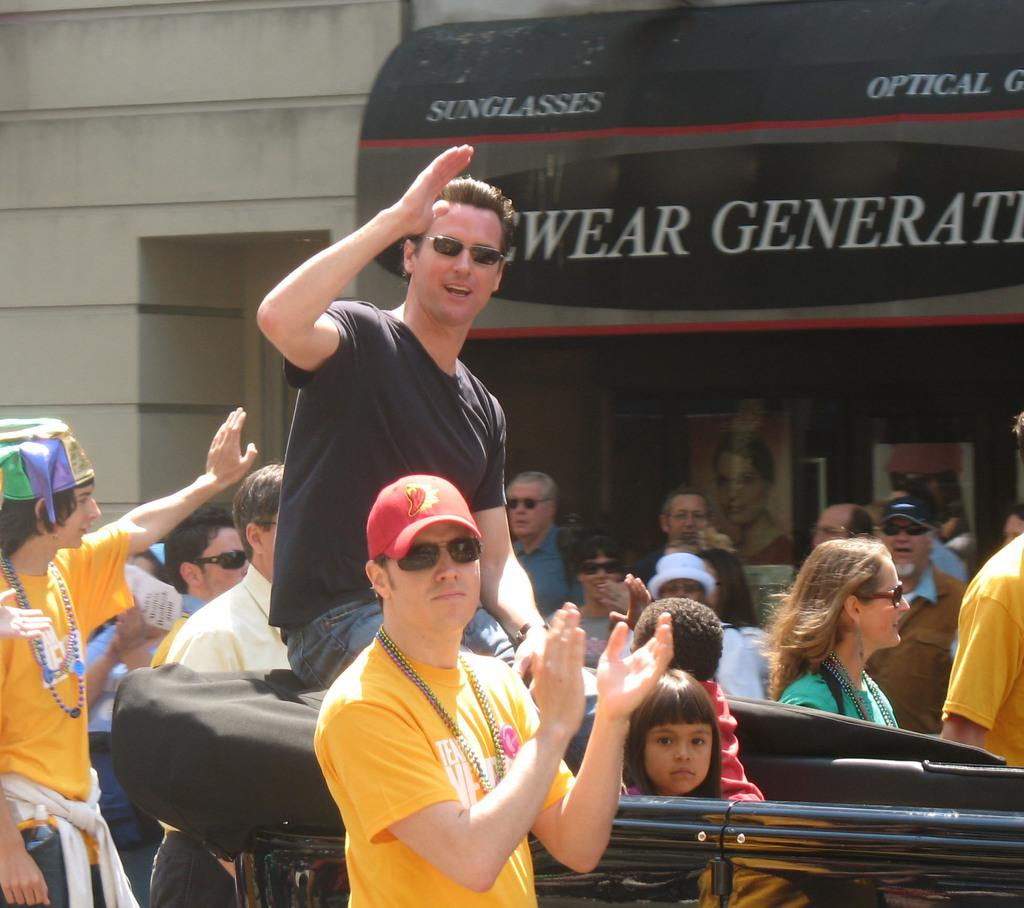What are the people in the image doing? There are people walking on the road and traveling in a vehicle in the image. Can you describe the mode of transportation in the image? The people are traveling in a vehicle, but the specific type of vehicle is not mentioned in the facts. How many people are visible in the image? The number of people visible in the image is not mentioned in the facts. What is the eye of the person in the image doing? There is no mention of a person's eye in the image, so it is not possible to answer that question. 